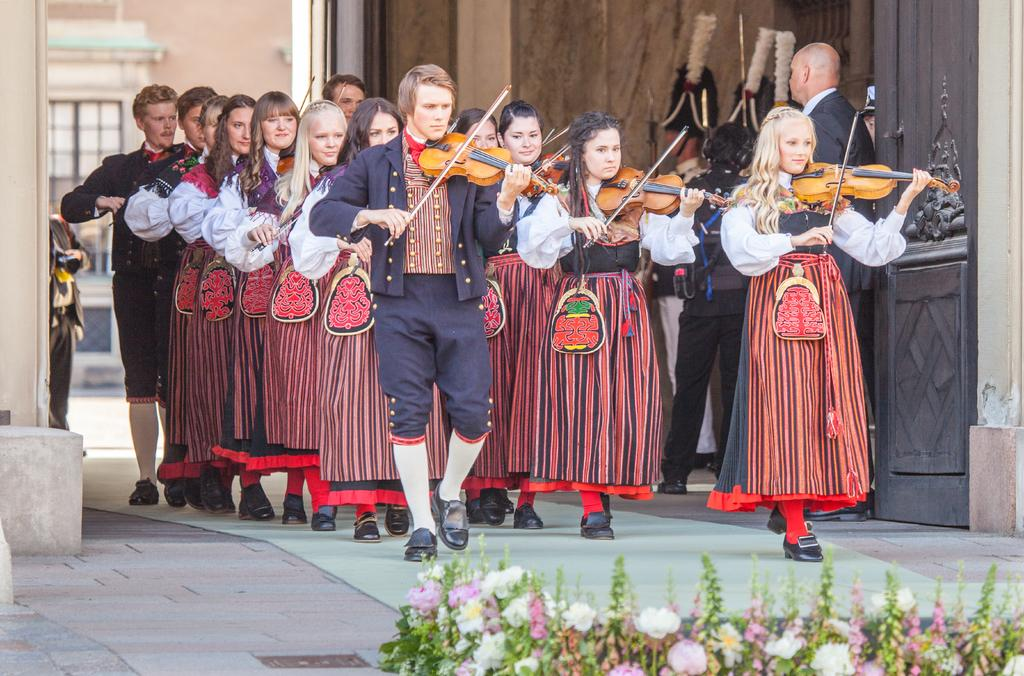How many people are in the image? There is a group of people in the image. What are the people doing in the image? Some of the people are playing violin. What is the setting of the image? There is a building in the image. Can you describe the floor in the image? The people are standing on the floor. What else can be seen in the image besides the people and the building? There are flowers in the image. What type of cord is being used by the person playing the violin in the image? There is no cord visible in the image; the violin is being played without any visible cords. 